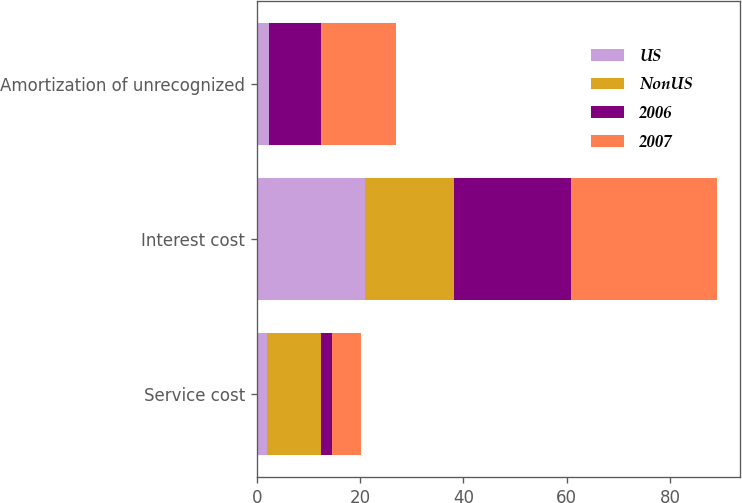<chart> <loc_0><loc_0><loc_500><loc_500><stacked_bar_chart><ecel><fcel>Service cost<fcel>Interest cost<fcel>Amortization of unrecognized<nl><fcel>US<fcel>2<fcel>20.9<fcel>2.3<nl><fcel>NonUS<fcel>10.4<fcel>17.3<fcel>0.1<nl><fcel>2006<fcel>2.2<fcel>22.7<fcel>10.1<nl><fcel>2007<fcel>5.5<fcel>28.2<fcel>14.4<nl></chart> 